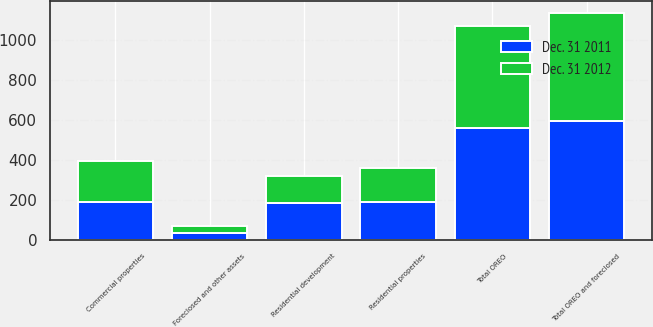Convert chart. <chart><loc_0><loc_0><loc_500><loc_500><stacked_bar_chart><ecel><fcel>Residential properties<fcel>Residential development<fcel>Commercial properties<fcel>Total OREO<fcel>Foreclosed and other assets<fcel>Total OREO and foreclosed<nl><fcel>Dec. 31 2012<fcel>167<fcel>135<fcel>205<fcel>507<fcel>33<fcel>540<nl><fcel>Dec. 31 2011<fcel>191<fcel>183<fcel>187<fcel>561<fcel>35<fcel>596<nl></chart> 